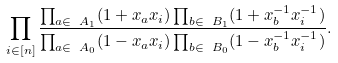Convert formula to latex. <formula><loc_0><loc_0><loc_500><loc_500>\prod _ { i \in [ n ] } \frac { \prod _ { a \in \ A _ { 1 } } ( 1 + x _ { a } x _ { i } ) \prod _ { b \in \ B _ { 1 } } ( 1 + x _ { b } ^ { - 1 } x _ { i } ^ { - 1 } ) } { \prod _ { a \in \ A _ { 0 } } ( 1 - x _ { a } x _ { i } ) \prod _ { b \in \ B _ { 0 } } ( 1 - x _ { b } ^ { - 1 } x _ { i } ^ { - 1 } ) } .</formula> 